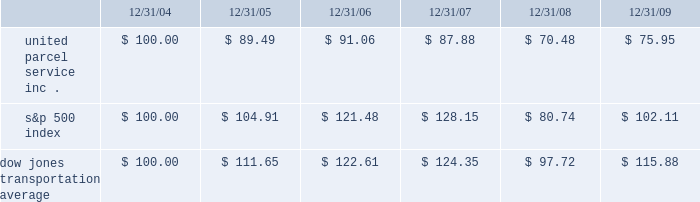( 1 ) includes shares repurchased through our publicly announced share repurchase program and shares tendered to pay the exercise price and tax withholding on employee stock options .
Shareowner return performance graph the following performance graph and related information shall not be deemed 201csoliciting material 201d or to be 201cfiled 201d with the securities and exchange commission , nor shall such information be incorporated by reference into any future filing under the securities act of 1933 or securities exchange act of 1934 , each as amended , except to the extent that the company specifically incorporates such information by reference into such filing .
The following graph shows a five-year comparison of cumulative total shareowners 2019 returns for our class b common stock , the s&p 500 index , and the dow jones transportation average .
The comparison of the total cumulative return on investment , which is the change in the quarterly stock price plus reinvested dividends for each of the quarterly periods , assumes that $ 100 was invested on december 31 , 2004 in the s&p 500 index , the dow jones transportation average , and our class b common stock .
Comparison of five year cumulative total return $ 40.00 $ 60.00 $ 80.00 $ 100.00 $ 120.00 $ 140.00 $ 160.00 2004 20092008200720062005 s&p 500 ups dj transport .

What was the percentage cumulative return on investment for united parcel service inc . for the five year period ended 12/31/09? 
Computations: ((75.95 - 100) / 100)
Answer: -0.2405. 